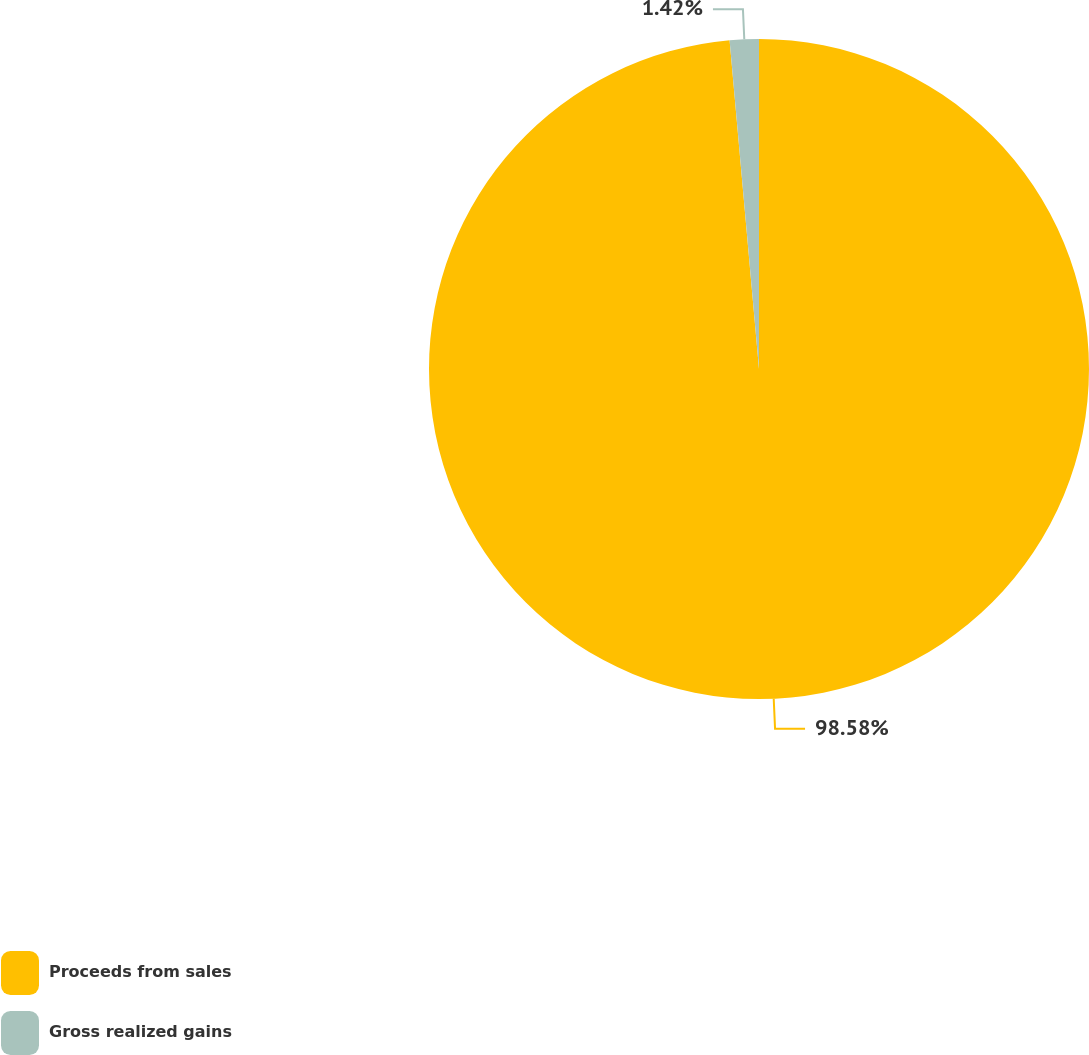<chart> <loc_0><loc_0><loc_500><loc_500><pie_chart><fcel>Proceeds from sales<fcel>Gross realized gains<nl><fcel>98.58%<fcel>1.42%<nl></chart> 